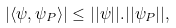<formula> <loc_0><loc_0><loc_500><loc_500>| \langle \psi , \psi _ { P } \rangle | \leq | | \psi | | . | | \psi _ { P } | | ,</formula> 